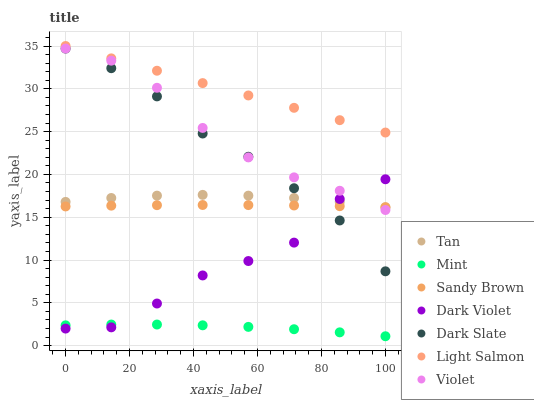Does Mint have the minimum area under the curve?
Answer yes or no. Yes. Does Light Salmon have the maximum area under the curve?
Answer yes or no. Yes. Does Dark Violet have the minimum area under the curve?
Answer yes or no. No. Does Dark Violet have the maximum area under the curve?
Answer yes or no. No. Is Light Salmon the smoothest?
Answer yes or no. Yes. Is Dark Violet the roughest?
Answer yes or no. Yes. Is Mint the smoothest?
Answer yes or no. No. Is Mint the roughest?
Answer yes or no. No. Does Mint have the lowest value?
Answer yes or no. Yes. Does Dark Violet have the lowest value?
Answer yes or no. No. Does Light Salmon have the highest value?
Answer yes or no. Yes. Does Dark Violet have the highest value?
Answer yes or no. No. Is Dark Violet less than Light Salmon?
Answer yes or no. Yes. Is Tan greater than Mint?
Answer yes or no. Yes. Does Dark Violet intersect Violet?
Answer yes or no. Yes. Is Dark Violet less than Violet?
Answer yes or no. No. Is Dark Violet greater than Violet?
Answer yes or no. No. Does Dark Violet intersect Light Salmon?
Answer yes or no. No. 